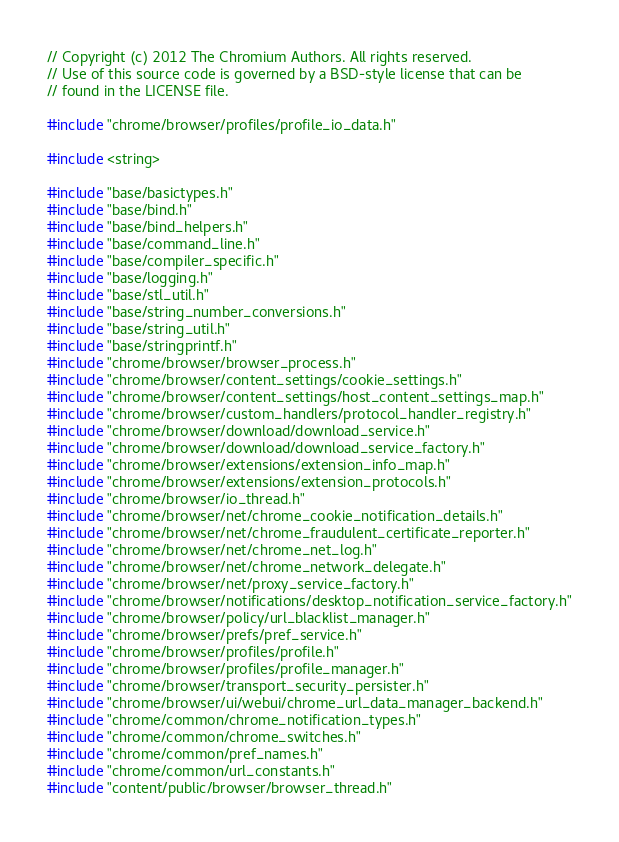<code> <loc_0><loc_0><loc_500><loc_500><_C++_>// Copyright (c) 2012 The Chromium Authors. All rights reserved.
// Use of this source code is governed by a BSD-style license that can be
// found in the LICENSE file.

#include "chrome/browser/profiles/profile_io_data.h"

#include <string>

#include "base/basictypes.h"
#include "base/bind.h"
#include "base/bind_helpers.h"
#include "base/command_line.h"
#include "base/compiler_specific.h"
#include "base/logging.h"
#include "base/stl_util.h"
#include "base/string_number_conversions.h"
#include "base/string_util.h"
#include "base/stringprintf.h"
#include "chrome/browser/browser_process.h"
#include "chrome/browser/content_settings/cookie_settings.h"
#include "chrome/browser/content_settings/host_content_settings_map.h"
#include "chrome/browser/custom_handlers/protocol_handler_registry.h"
#include "chrome/browser/download/download_service.h"
#include "chrome/browser/download/download_service_factory.h"
#include "chrome/browser/extensions/extension_info_map.h"
#include "chrome/browser/extensions/extension_protocols.h"
#include "chrome/browser/io_thread.h"
#include "chrome/browser/net/chrome_cookie_notification_details.h"
#include "chrome/browser/net/chrome_fraudulent_certificate_reporter.h"
#include "chrome/browser/net/chrome_net_log.h"
#include "chrome/browser/net/chrome_network_delegate.h"
#include "chrome/browser/net/proxy_service_factory.h"
#include "chrome/browser/notifications/desktop_notification_service_factory.h"
#include "chrome/browser/policy/url_blacklist_manager.h"
#include "chrome/browser/prefs/pref_service.h"
#include "chrome/browser/profiles/profile.h"
#include "chrome/browser/profiles/profile_manager.h"
#include "chrome/browser/transport_security_persister.h"
#include "chrome/browser/ui/webui/chrome_url_data_manager_backend.h"
#include "chrome/common/chrome_notification_types.h"
#include "chrome/common/chrome_switches.h"
#include "chrome/common/pref_names.h"
#include "chrome/common/url_constants.h"
#include "content/public/browser/browser_thread.h"</code> 